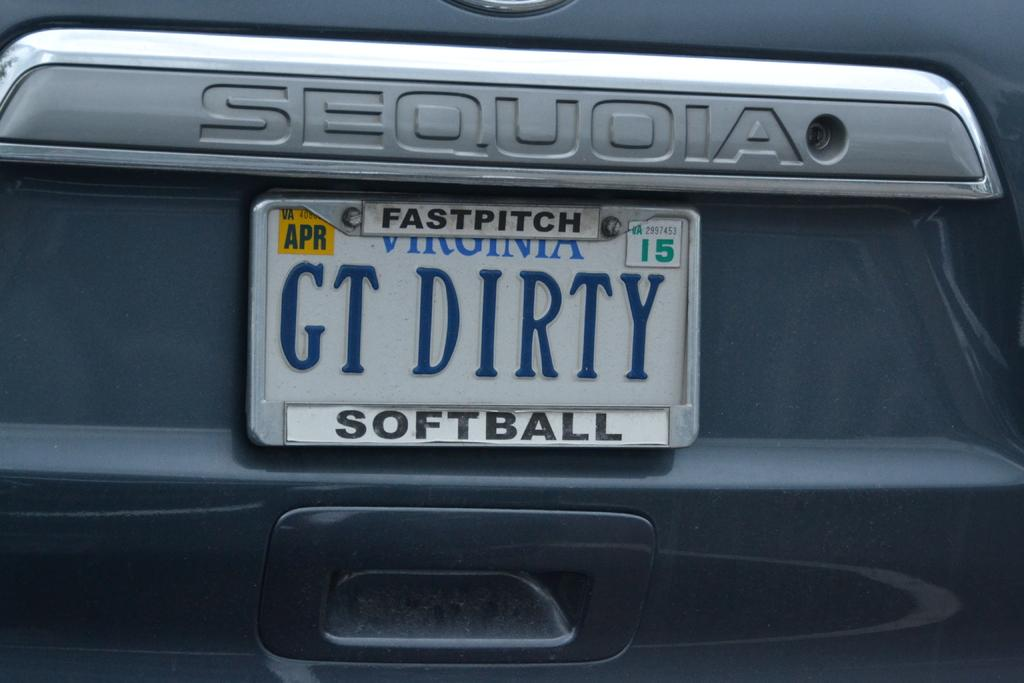<image>
Write a terse but informative summary of the picture. A Sequoia has a license plate frame that says fastpitch softball. 